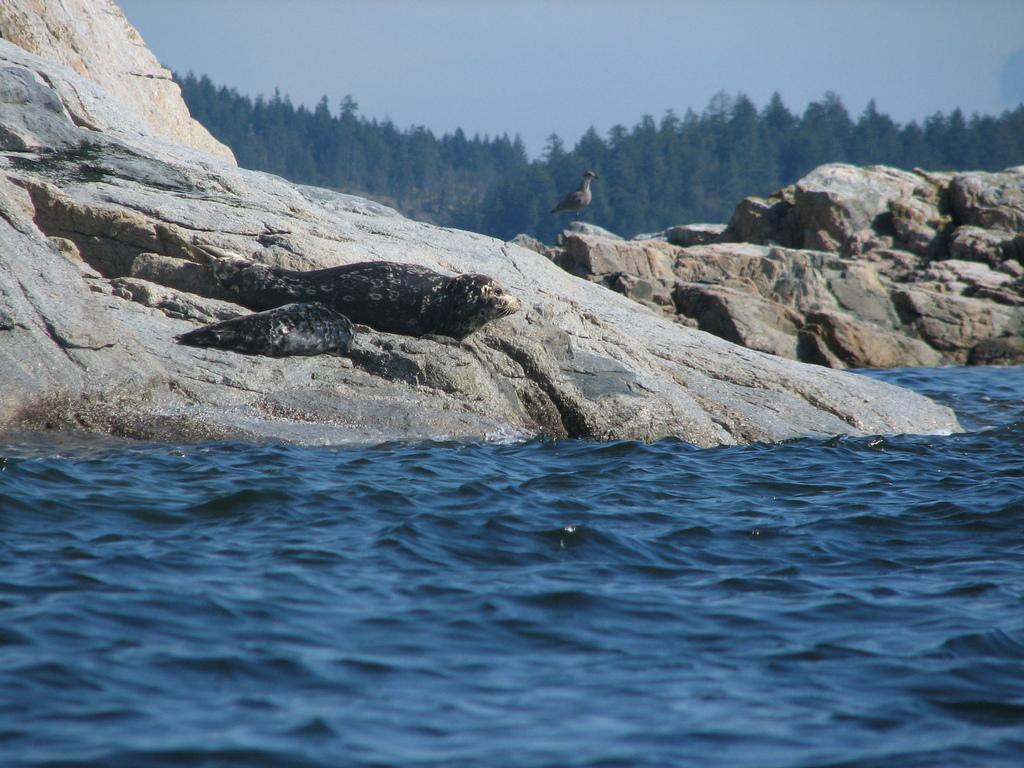In one or two sentences, can you explain what this image depicts? In this picture we can see water at the bottom, there are some rocks and a bird in the middle, in the background there are some trees, we can see the sky at the top of the picture. 